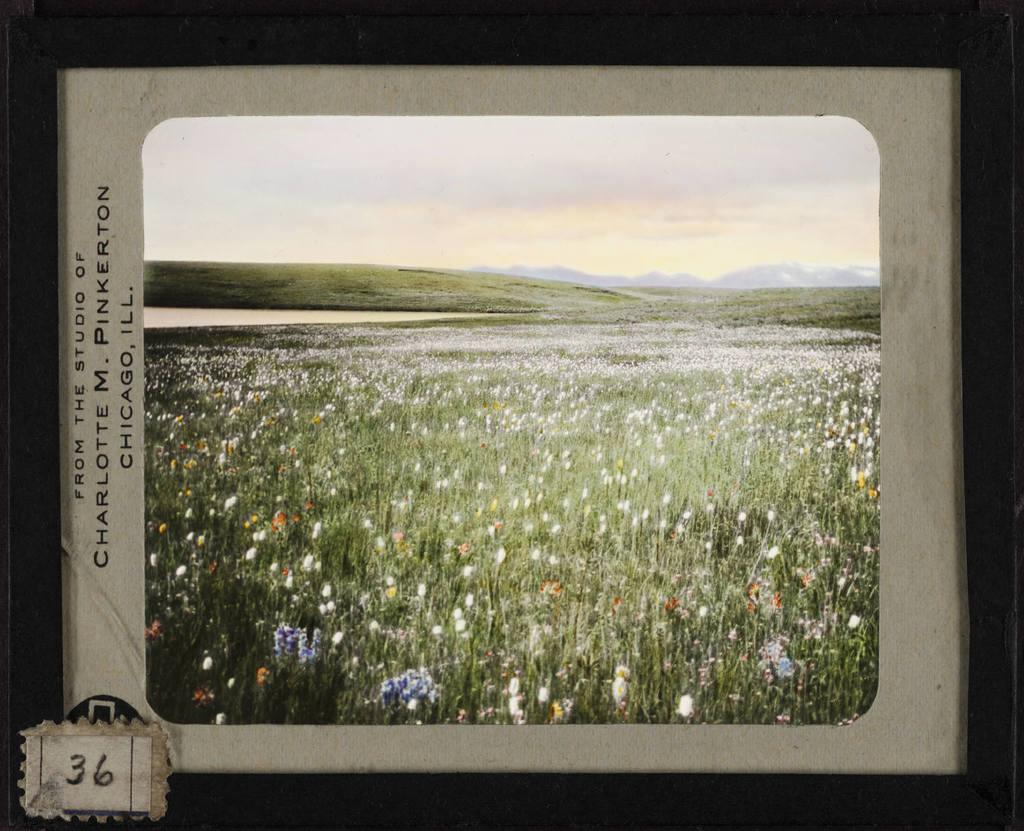<image>
Describe the image concisely. slide of a field of wildflowers from the studio of charlotte m pinkerton 